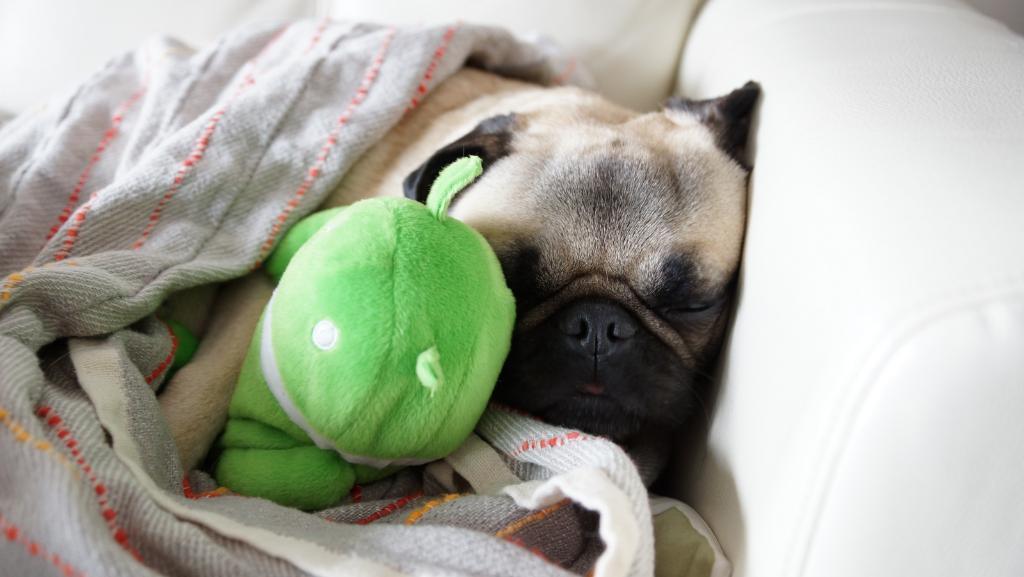Can you describe this image briefly? There is a dog sleeping in the sofa which is in white colour. The dog breed name is pug. The dog is covered with a blanket. Beside the dog there is a teddy bear which is green in colour. 